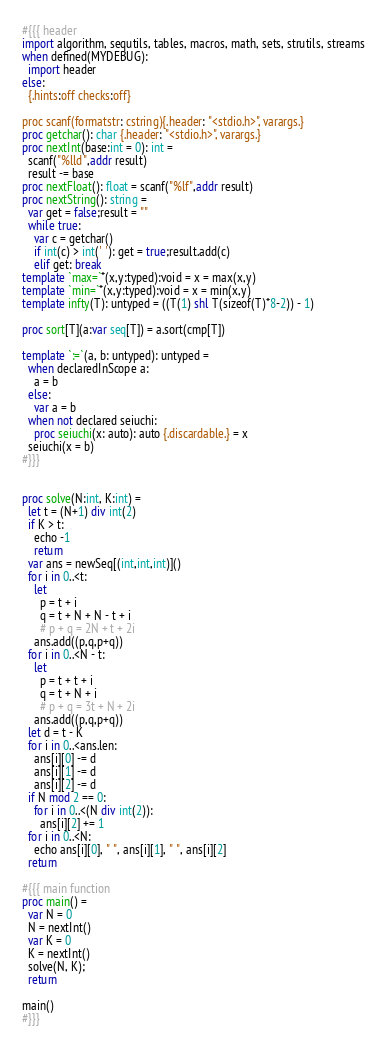<code> <loc_0><loc_0><loc_500><loc_500><_Nim_>#{{{ header
import algorithm, sequtils, tables, macros, math, sets, strutils, streams
when defined(MYDEBUG):
  import header
else:
  {.hints:off checks:off}

proc scanf(formatstr: cstring){.header: "<stdio.h>", varargs.}
proc getchar(): char {.header: "<stdio.h>", varargs.}
proc nextInt(base:int = 0): int =
  scanf("%lld",addr result)
  result -= base
proc nextFloat(): float = scanf("%lf",addr result)
proc nextString(): string =
  var get = false;result = ""
  while true:
    var c = getchar()
    if int(c) > int(' '): get = true;result.add(c)
    elif get: break
template `max=`*(x,y:typed):void = x = max(x,y)
template `min=`*(x,y:typed):void = x = min(x,y)
template infty(T): untyped = ((T(1) shl T(sizeof(T)*8-2)) - 1)

proc sort[T](a:var seq[T]) = a.sort(cmp[T])

template `:=`(a, b: untyped): untyped =
  when declaredInScope a:
    a = b
  else:
    var a = b
  when not declared seiuchi:
    proc seiuchi(x: auto): auto {.discardable.} = x
  seiuchi(x = b)
#}}}


proc solve(N:int, K:int) =
  let t = (N+1) div int(2)
  if K > t:
    echo -1
    return
  var ans = newSeq[(int,int,int)]()
  for i in 0..<t:
    let
      p = t + i
      q = t + N + N - t + i
      # p + q = 2N + t + 2i
    ans.add((p,q,p+q))
  for i in 0..<N - t:
    let
      p = t + t + i
      q = t + N + i
      # p + q = 3t + N + 2i
    ans.add((p,q,p+q))
  let d = t - K
  for i in 0..<ans.len:
    ans[i][0] -= d
    ans[i][1] -= d
    ans[i][2] -= d
  if N mod 2 == 0:
    for i in 0..<(N div int(2)):
      ans[i][2] += 1
  for i in 0..<N:
    echo ans[i][0], " ", ans[i][1], " ", ans[i][2]
  return

#{{{ main function
proc main() =
  var N = 0
  N = nextInt()
  var K = 0
  K = nextInt()
  solve(N, K);
  return

main()
#}}}</code> 